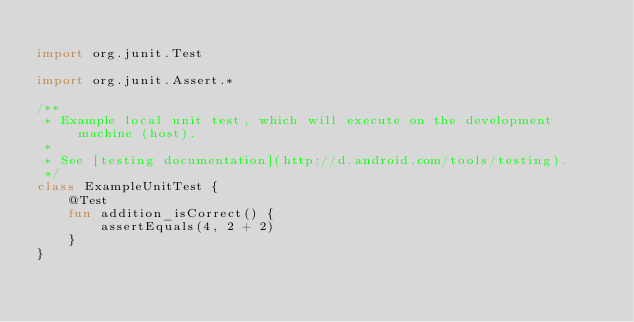<code> <loc_0><loc_0><loc_500><loc_500><_Kotlin_>
import org.junit.Test

import org.junit.Assert.*

/**
 * Example local unit test, which will execute on the development machine (host).
 *
 * See [testing documentation](http://d.android.com/tools/testing).
 */
class ExampleUnitTest {
    @Test
    fun addition_isCorrect() {
        assertEquals(4, 2 + 2)
    }
}</code> 